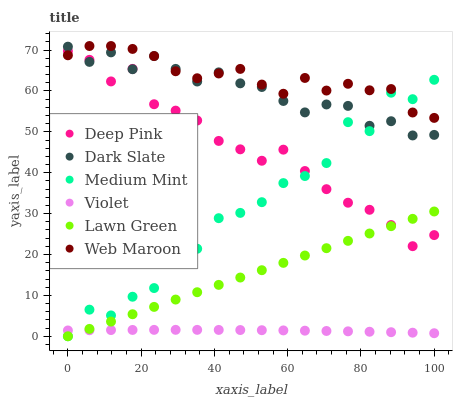Does Violet have the minimum area under the curve?
Answer yes or no. Yes. Does Web Maroon have the maximum area under the curve?
Answer yes or no. Yes. Does Lawn Green have the minimum area under the curve?
Answer yes or no. No. Does Lawn Green have the maximum area under the curve?
Answer yes or no. No. Is Lawn Green the smoothest?
Answer yes or no. Yes. Is Medium Mint the roughest?
Answer yes or no. Yes. Is Deep Pink the smoothest?
Answer yes or no. No. Is Deep Pink the roughest?
Answer yes or no. No. Does Medium Mint have the lowest value?
Answer yes or no. Yes. Does Deep Pink have the lowest value?
Answer yes or no. No. Does Web Maroon have the highest value?
Answer yes or no. Yes. Does Lawn Green have the highest value?
Answer yes or no. No. Is Violet less than Dark Slate?
Answer yes or no. Yes. Is Web Maroon greater than Violet?
Answer yes or no. Yes. Does Dark Slate intersect Medium Mint?
Answer yes or no. Yes. Is Dark Slate less than Medium Mint?
Answer yes or no. No. Is Dark Slate greater than Medium Mint?
Answer yes or no. No. Does Violet intersect Dark Slate?
Answer yes or no. No. 